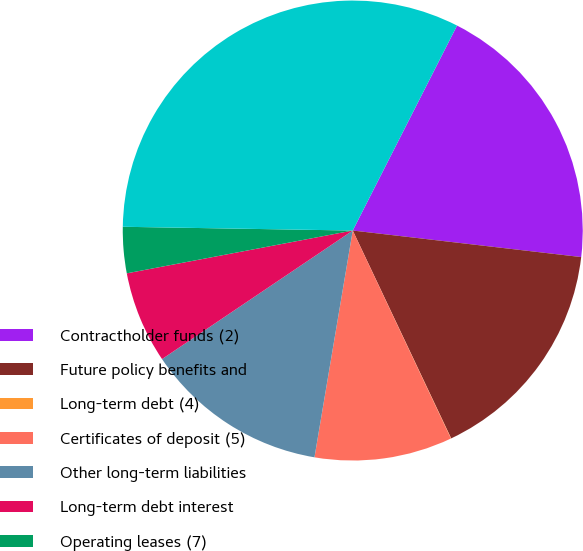<chart> <loc_0><loc_0><loc_500><loc_500><pie_chart><fcel>Contractholder funds (2)<fcel>Future policy benefits and<fcel>Long-term debt (4)<fcel>Certificates of deposit (5)<fcel>Other long-term liabilities<fcel>Long-term debt interest<fcel>Operating leases (7)<fcel>Total contractual obligations<nl><fcel>19.35%<fcel>16.12%<fcel>0.02%<fcel>9.68%<fcel>12.9%<fcel>6.46%<fcel>3.24%<fcel>32.23%<nl></chart> 